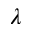Convert formula to latex. <formula><loc_0><loc_0><loc_500><loc_500>\lambda</formula> 